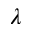Convert formula to latex. <formula><loc_0><loc_0><loc_500><loc_500>\lambda</formula> 